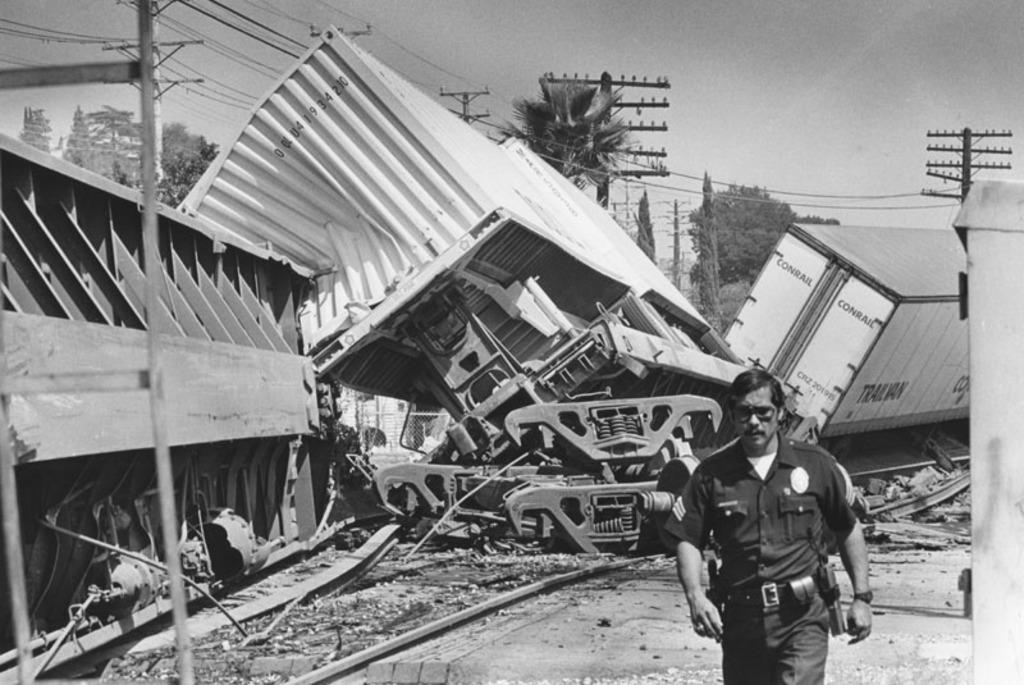Can you describe this image briefly? In this image I can see a man is wearing a uniform. In the background I can see containers, poles which has wires, trees and the sky. This picture is black and white in color. 